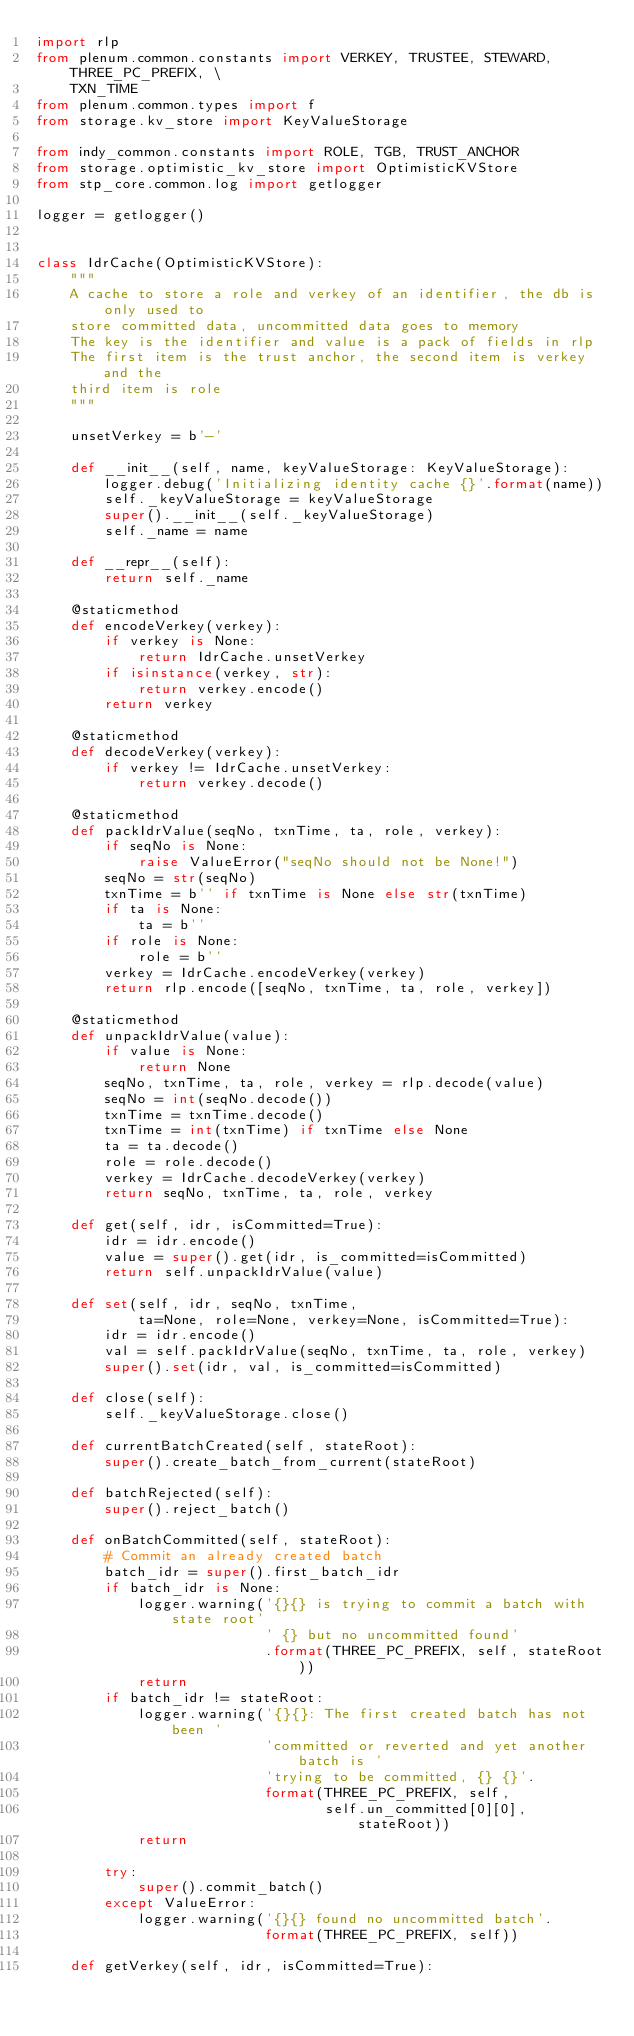<code> <loc_0><loc_0><loc_500><loc_500><_Python_>import rlp
from plenum.common.constants import VERKEY, TRUSTEE, STEWARD, THREE_PC_PREFIX, \
    TXN_TIME
from plenum.common.types import f
from storage.kv_store import KeyValueStorage

from indy_common.constants import ROLE, TGB, TRUST_ANCHOR
from storage.optimistic_kv_store import OptimisticKVStore
from stp_core.common.log import getlogger

logger = getlogger()


class IdrCache(OptimisticKVStore):
    """
    A cache to store a role and verkey of an identifier, the db is only used to
    store committed data, uncommitted data goes to memory
    The key is the identifier and value is a pack of fields in rlp
    The first item is the trust anchor, the second item is verkey and the
    third item is role
    """

    unsetVerkey = b'-'

    def __init__(self, name, keyValueStorage: KeyValueStorage):
        logger.debug('Initializing identity cache {}'.format(name))
        self._keyValueStorage = keyValueStorage
        super().__init__(self._keyValueStorage)
        self._name = name

    def __repr__(self):
        return self._name

    @staticmethod
    def encodeVerkey(verkey):
        if verkey is None:
            return IdrCache.unsetVerkey
        if isinstance(verkey, str):
            return verkey.encode()
        return verkey

    @staticmethod
    def decodeVerkey(verkey):
        if verkey != IdrCache.unsetVerkey:
            return verkey.decode()

    @staticmethod
    def packIdrValue(seqNo, txnTime, ta, role, verkey):
        if seqNo is None:
            raise ValueError("seqNo should not be None!")
        seqNo = str(seqNo)
        txnTime = b'' if txnTime is None else str(txnTime)
        if ta is None:
            ta = b''
        if role is None:
            role = b''
        verkey = IdrCache.encodeVerkey(verkey)
        return rlp.encode([seqNo, txnTime, ta, role, verkey])

    @staticmethod
    def unpackIdrValue(value):
        if value is None:
            return None
        seqNo, txnTime, ta, role, verkey = rlp.decode(value)
        seqNo = int(seqNo.decode())
        txnTime = txnTime.decode()
        txnTime = int(txnTime) if txnTime else None
        ta = ta.decode()
        role = role.decode()
        verkey = IdrCache.decodeVerkey(verkey)
        return seqNo, txnTime, ta, role, verkey

    def get(self, idr, isCommitted=True):
        idr = idr.encode()
        value = super().get(idr, is_committed=isCommitted)
        return self.unpackIdrValue(value)

    def set(self, idr, seqNo, txnTime,
            ta=None, role=None, verkey=None, isCommitted=True):
        idr = idr.encode()
        val = self.packIdrValue(seqNo, txnTime, ta, role, verkey)
        super().set(idr, val, is_committed=isCommitted)

    def close(self):
        self._keyValueStorage.close()

    def currentBatchCreated(self, stateRoot):
        super().create_batch_from_current(stateRoot)

    def batchRejected(self):
        super().reject_batch()

    def onBatchCommitted(self, stateRoot):
        # Commit an already created batch
        batch_idr = super().first_batch_idr
        if batch_idr is None:
            logger.warning('{}{} is trying to commit a batch with state root'
                           ' {} but no uncommitted found'
                           .format(THREE_PC_PREFIX, self, stateRoot))
            return
        if batch_idr != stateRoot:
            logger.warning('{}{}: The first created batch has not been '
                           'committed or reverted and yet another batch is '
                           'trying to be committed, {} {}'.
                           format(THREE_PC_PREFIX, self,
                                  self.un_committed[0][0], stateRoot))
            return

        try:
            super().commit_batch()
        except ValueError:
            logger.warning('{}{} found no uncommitted batch'.
                           format(THREE_PC_PREFIX, self))

    def getVerkey(self, idr, isCommitted=True):</code> 